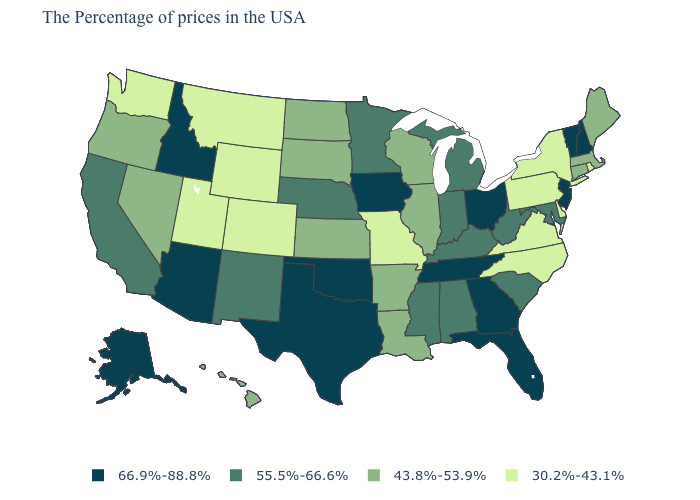Does the map have missing data?
Concise answer only. No. Does New York have a higher value than South Carolina?
Keep it brief. No. Does the map have missing data?
Keep it brief. No. What is the value of Arkansas?
Short answer required. 43.8%-53.9%. What is the highest value in the USA?
Keep it brief. 66.9%-88.8%. Does Idaho have the same value as Nevada?
Short answer required. No. What is the lowest value in the MidWest?
Answer briefly. 30.2%-43.1%. What is the value of Connecticut?
Quick response, please. 43.8%-53.9%. What is the highest value in the MidWest ?
Give a very brief answer. 66.9%-88.8%. Does Florida have the same value as Texas?
Answer briefly. Yes. What is the value of Tennessee?
Quick response, please. 66.9%-88.8%. Which states have the lowest value in the USA?
Be succinct. Rhode Island, New York, Delaware, Pennsylvania, Virginia, North Carolina, Missouri, Wyoming, Colorado, Utah, Montana, Washington. Is the legend a continuous bar?
Answer briefly. No. Does the map have missing data?
Keep it brief. No. Among the states that border Nebraska , does Missouri have the lowest value?
Short answer required. Yes. 